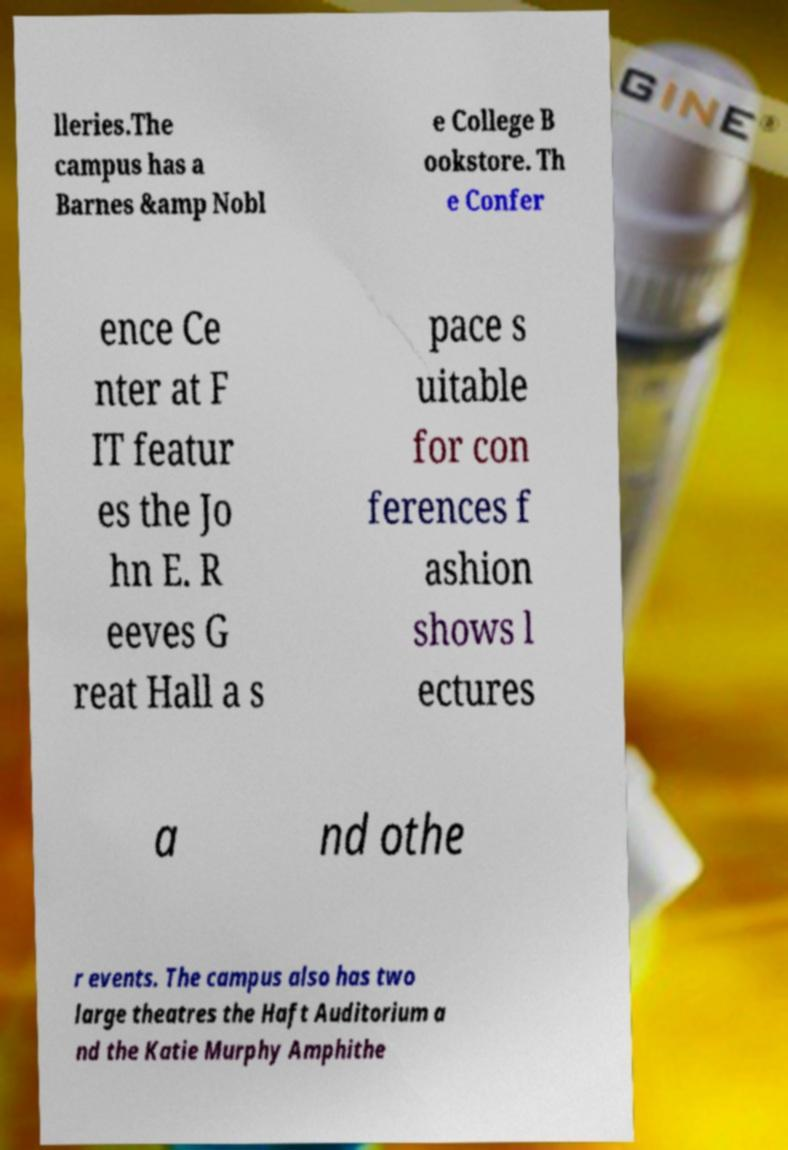Please read and relay the text visible in this image. What does it say? lleries.The campus has a Barnes &amp Nobl e College B ookstore. Th e Confer ence Ce nter at F IT featur es the Jo hn E. R eeves G reat Hall a s pace s uitable for con ferences f ashion shows l ectures a nd othe r events. The campus also has two large theatres the Haft Auditorium a nd the Katie Murphy Amphithe 